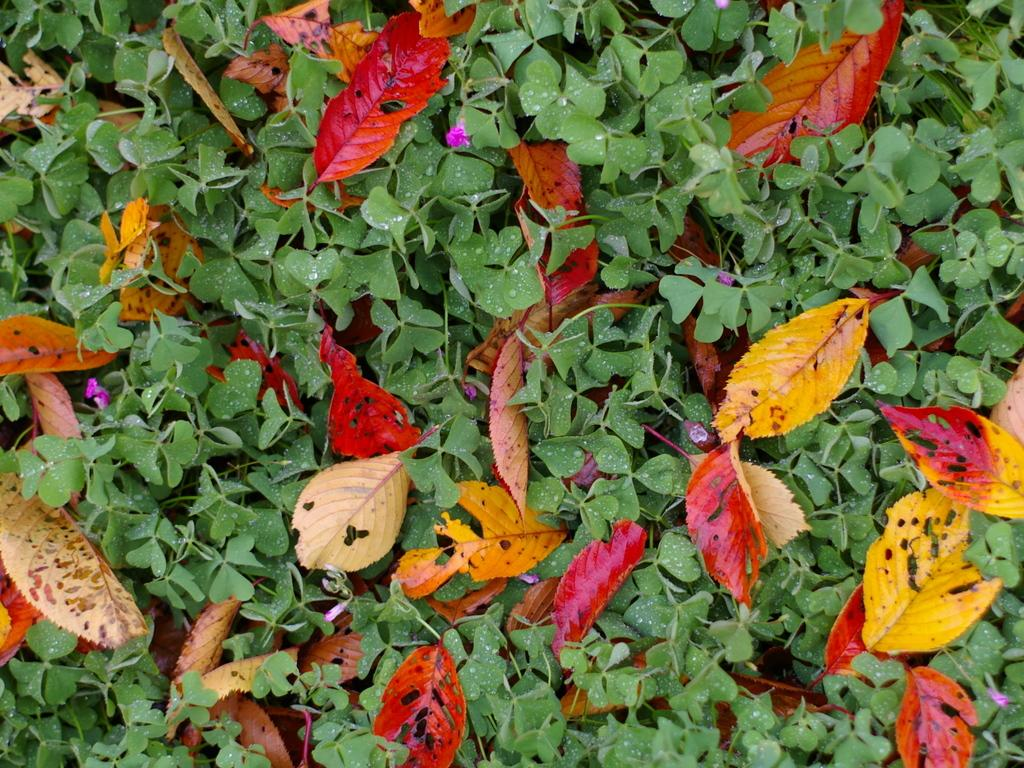What type of plants can be seen in the image? There are green color plants in the image. What is unique about the leaves of these plants? The leaves in the image are colorful. Can you see any snails crawling on the plants in the image? There is no mention of snails in the provided facts, so we cannot determine if they are present in the image. 